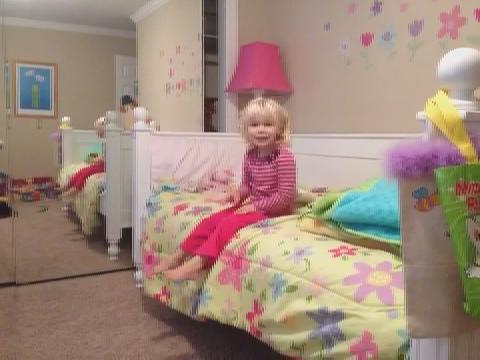What type of finish or item covers the back wall?

Choices:
A) mirror
B) silver paint
C) another room
D) white paint mirror 